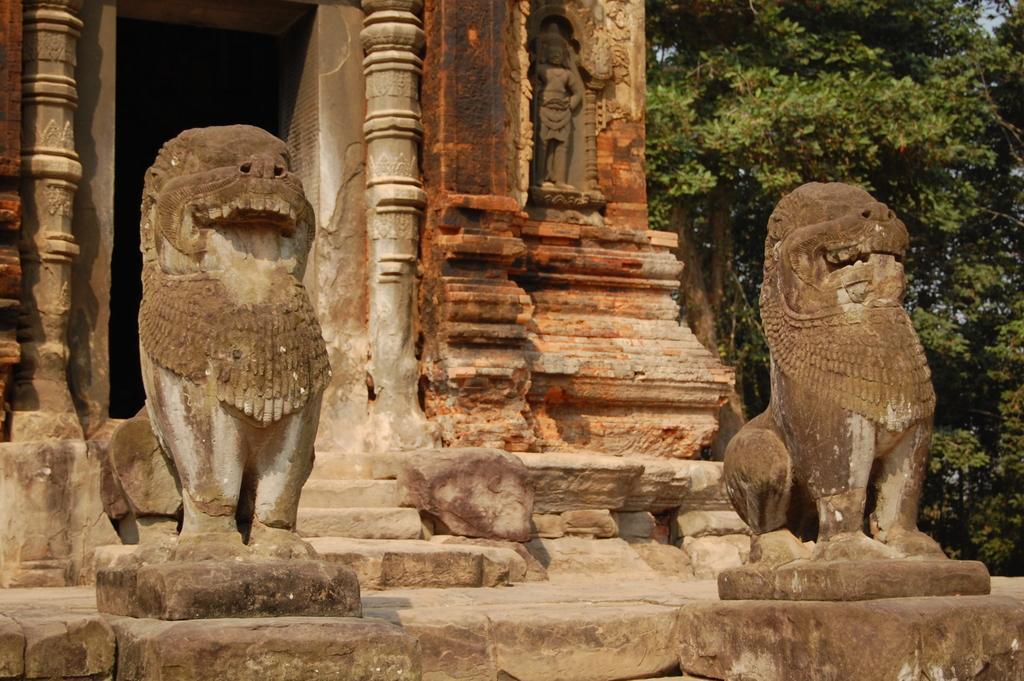What type of structure is depicted in the image? There is a historical temple construction in the image. Are there any specific features near the temple? Yes, there are two lion sculptures near the temple. What can be seen in the background of the image? There are trees visible in the image. What book is the lion holding in the image? There is no book present in the image; the lions are sculptures and do not hold objects. 